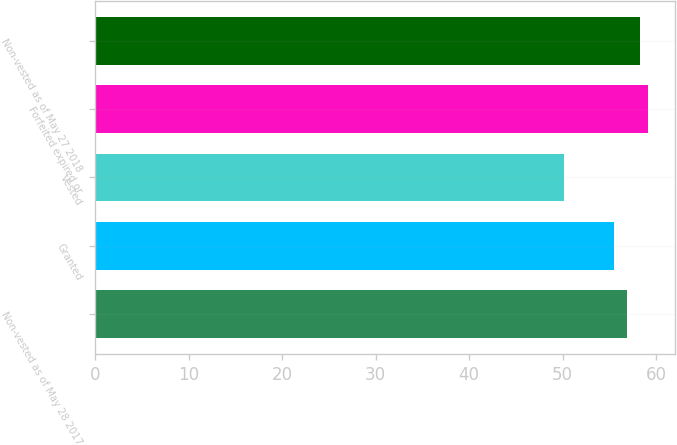<chart> <loc_0><loc_0><loc_500><loc_500><bar_chart><fcel>Non-vested as of May 28 2017<fcel>Granted<fcel>Vested<fcel>Forfeited expired or<fcel>Non-vested as of May 27 2018<nl><fcel>56.93<fcel>55.48<fcel>50.14<fcel>59.12<fcel>58.26<nl></chart> 